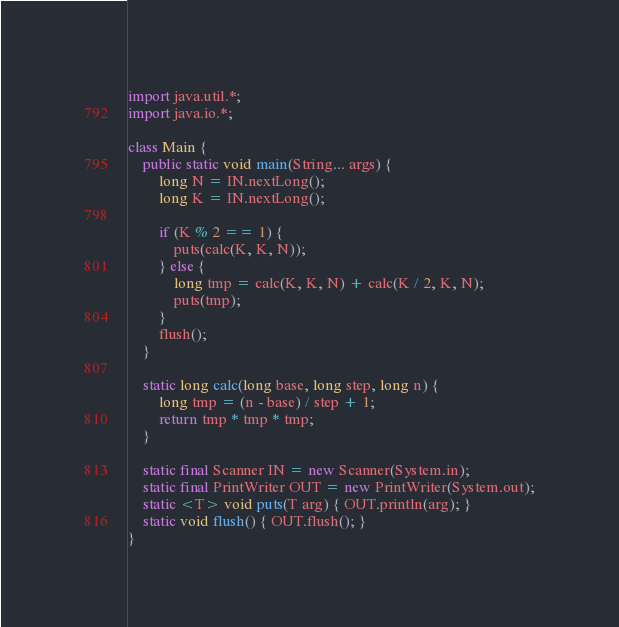<code> <loc_0><loc_0><loc_500><loc_500><_Java_>import java.util.*;
import java.io.*;

class Main {
	public static void main(String... args) {
		long N = IN.nextLong();
		long K = IN.nextLong();

		if (K % 2 == 1) {
			puts(calc(K, K, N));
		} else {
			long tmp = calc(K, K, N) + calc(K / 2, K, N);
			puts(tmp);
		}
		flush();
	}

	static long calc(long base, long step, long n) {
		long tmp = (n - base) / step + 1;
		return tmp * tmp * tmp;
	}

	static final Scanner IN = new Scanner(System.in);
	static final PrintWriter OUT = new PrintWriter(System.out);
	static <T> void puts(T arg) { OUT.println(arg); }
	static void flush() { OUT.flush(); }
}
</code> 